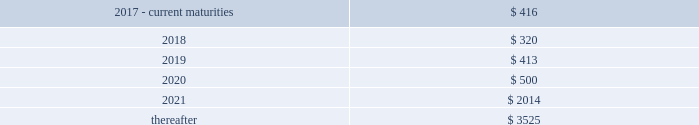F-772016 annual report the hartford financial services group , inc .
Notes to consolidated financial statements ( continued ) 13 .
Debt ( continued ) the 7.875% ( 7.875 % ) and 8.125% ( 8.125 % ) debentures may be redeemed in whole prior to the call date upon certain tax or rating agency events , at a price equal to the greater of 100% ( 100 % ) of the principal amount being redeemed and the applicable make-whole amount plus any accrued and unpaid interest .
The company may elect to redeem the 8.125% ( 8.125 % ) debentures in whole or part at its option prior to the call date at a price equal to the greater of 100% ( 100 % ) of the principal amount being redeemed and the applicable make-whole amount plus any accrued and unpaid interest .
The company may elect to redeem the 7.875% ( 7.875 % ) and 8.125% ( 8.125 % ) debentures in whole or in part on or after the call date for the principal amount being redeemed plus accrued and unpaid interest to the date of redemption .
In connection with the offering of the 8.125% ( 8.125 % ) debentures , the company entered into a replacement capital covenant ( 201crcc 201d ) for the benefit of holders of one or more designated series of the company 2019s indebtedness , initially the company 2019s 6.1% ( 6.1 % ) notes due 2041 .
Under the terms of the rcc , if the company redeems the 8.125% ( 8.125 % ) debentures at any time prior to june 15 , 2048 it can only do so with the proceeds from the sale of certain qualifying replacement securities .
On february 7 , 2017 , the company executed an amendment to the rcc to lengthen the amount of time the company has to issue qualifying replacement securities prior to the redemption of the 8.125% ( 8.125 % ) debentures and to amend the definition of certain qualifying replacement securities .
Long-term debt long-term debt maturities ( at par value ) as of december 31 , 2016 .
Shelf registrations on july 29 , 2016 , the company filed with the securities and exchange commission ( the 201csec 201d ) an automatic shelf registration statement ( registration no .
333-212778 ) for the potential offering and sale of debt and equity securities .
The registration statement allows for the following types of securities to be offered : debt securities , junior subordinated debt securities , preferred stock , common stock , depositary shares , warrants , stock purchase contracts , and stock purchase units .
In that the hartford is a well- known seasoned issuer , as defined in rule 405 under the securities act of 1933 , the registration statement went effective immediately upon filing and the hartford may offer and sell an unlimited amount of securities under the registration statement during the three-year life of the registration statement .
Contingent capital facility the hartford is party to a put option agreement that provides the hartford with the right to require the glen meadow abc trust , a delaware statutory trust , at any time and from time to time , to purchase the hartford 2019s junior subordinated notes in a maximum aggregate principal amount not to exceed $ 500 .
On february 8 , 2017 , the hartford exercised the put option resulting in the issuance of $ 500 in junior subordinated notes with proceeds received on february 15 , 2017 .
Under the put option agreement , the hartford had been paying the glen meadow abc trust premiums on a periodic basis , calculated with respect to the aggregate principal amount of notes that the hartford had the right to put to the glen meadow abc trust for such period .
The hartford has agreed to reimburse the glen meadow abc trust for certain fees and ordinary expenses .
The company holds a variable interest in the glen meadow abc trust where the company is not the primary beneficiary .
As a result , the company does not consolidate the glen meadow abc trust .
The junior subordinated notes have a scheduled maturity of february 12 , 2047 , and a final maturity of february 12 , 2067 .
The company is required to use reasonable efforts to sell certain qualifying replacement securities in order to repay the debentures at the scheduled maturity date .
The junior subordinated notes bear interest at an annual rate of three-month libor plus 2.125% ( 2.125 % ) , payable quarterly , and are unsecured , subordinated indebtedness of the hartford .
The hartford will have the right , on one or more occasions , to defer interest payments due on the junior subordinated notes under specified circumstances .
Upon receipt of the proceeds , the company entered into a replacement capital covenant ( the 201crcc 201d ) for the benefit of holders of one or more designated series of the company 2019s indebtedness , initially the company 2019s 4.3% ( 4.3 % ) notes due 2043 .
Under the terms of the rcc , if the company redeems the debentures at any time prior to february 12 , 2047 ( or such earlier date on which the rcc terminates by its terms ) it can only do so with the proceeds from the sale of certain qualifying replacement securities .
The rcc also prohibits the company from redeeming all or any portion of the notes on or prior to february 15 , 2022 .
Revolving credit facilities the company has a senior unsecured five-year revolving credit facility ( the 201ccredit facility 201d ) that provides for borrowing capacity up to $ 1 billion of unsecured credit through october 31 , 2019 available in u.s .
Dollars , euro , sterling , canadian dollars and japanese yen .
As of december 31 , 2016 , no borrowings were outstanding under the credit facility .
As of december 31 , 2016 , the company was in compliance with all financial covenants within the credit facility .
Commercial paper the hartford 2019s maximum borrowings available under its commercial paper program are $ 1 billion .
The company is dependent upon market conditions to access short-term financing through the issuance of commercial paper to investors .
As of december 31 , 2016 , there was no commercial paper outstanding. .
As of december 2016 what was the average long-term debt maturities that was due between 2017 and 2020 in millions? 
Computations: (((500 + (413 + (416 + 320))) + 4) / 2)
Answer: 826.5. 